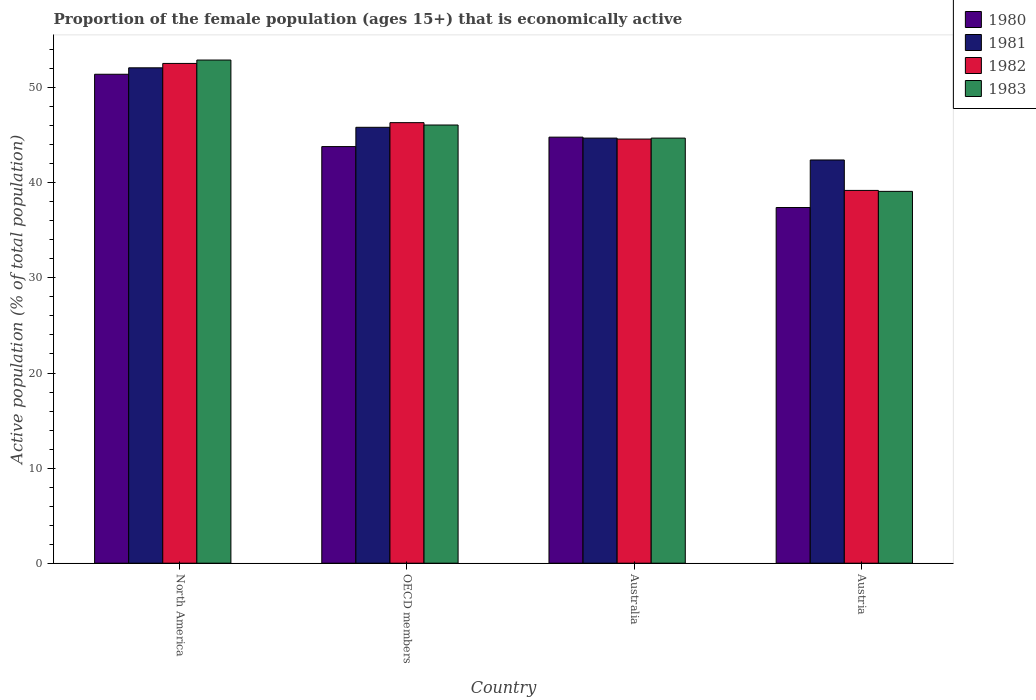How many different coloured bars are there?
Keep it short and to the point. 4. How many groups of bars are there?
Provide a succinct answer. 4. Are the number of bars per tick equal to the number of legend labels?
Give a very brief answer. Yes. Are the number of bars on each tick of the X-axis equal?
Provide a short and direct response. Yes. How many bars are there on the 4th tick from the left?
Your answer should be very brief. 4. What is the label of the 3rd group of bars from the left?
Provide a succinct answer. Australia. What is the proportion of the female population that is economically active in 1980 in OECD members?
Your response must be concise. 43.81. Across all countries, what is the maximum proportion of the female population that is economically active in 1982?
Offer a terse response. 52.55. Across all countries, what is the minimum proportion of the female population that is economically active in 1983?
Provide a succinct answer. 39.1. In which country was the proportion of the female population that is economically active in 1981 minimum?
Offer a very short reply. Austria. What is the total proportion of the female population that is economically active in 1980 in the graph?
Offer a very short reply. 177.42. What is the difference between the proportion of the female population that is economically active in 1981 in Australia and that in Austria?
Offer a terse response. 2.3. What is the difference between the proportion of the female population that is economically active in 1981 in Austria and the proportion of the female population that is economically active in 1980 in Australia?
Your answer should be compact. -2.4. What is the average proportion of the female population that is economically active in 1981 per country?
Keep it short and to the point. 46.26. What is the difference between the proportion of the female population that is economically active of/in 1981 and proportion of the female population that is economically active of/in 1980 in OECD members?
Your answer should be compact. 2.03. In how many countries, is the proportion of the female population that is economically active in 1983 greater than 52 %?
Offer a terse response. 1. What is the ratio of the proportion of the female population that is economically active in 1982 in Austria to that in North America?
Offer a very short reply. 0.75. Is the proportion of the female population that is economically active in 1980 in North America less than that in OECD members?
Offer a very short reply. No. What is the difference between the highest and the second highest proportion of the female population that is economically active in 1983?
Offer a very short reply. 6.83. What is the difference between the highest and the lowest proportion of the female population that is economically active in 1982?
Keep it short and to the point. 13.35. Is the sum of the proportion of the female population that is economically active in 1982 in Austria and North America greater than the maximum proportion of the female population that is economically active in 1983 across all countries?
Make the answer very short. Yes. What does the 2nd bar from the left in OECD members represents?
Make the answer very short. 1981. Is it the case that in every country, the sum of the proportion of the female population that is economically active in 1983 and proportion of the female population that is economically active in 1980 is greater than the proportion of the female population that is economically active in 1981?
Make the answer very short. Yes. Are all the bars in the graph horizontal?
Provide a short and direct response. No. Does the graph contain any zero values?
Provide a short and direct response. No. Where does the legend appear in the graph?
Make the answer very short. Top right. How many legend labels are there?
Give a very brief answer. 4. How are the legend labels stacked?
Your answer should be very brief. Vertical. What is the title of the graph?
Keep it short and to the point. Proportion of the female population (ages 15+) that is economically active. Does "1999" appear as one of the legend labels in the graph?
Your answer should be compact. No. What is the label or title of the Y-axis?
Ensure brevity in your answer.  Active population (% of total population). What is the Active population (% of total population) in 1980 in North America?
Provide a short and direct response. 51.41. What is the Active population (% of total population) in 1981 in North America?
Offer a very short reply. 52.09. What is the Active population (% of total population) of 1982 in North America?
Your response must be concise. 52.55. What is the Active population (% of total population) of 1983 in North America?
Provide a short and direct response. 52.91. What is the Active population (% of total population) in 1980 in OECD members?
Provide a short and direct response. 43.81. What is the Active population (% of total population) in 1981 in OECD members?
Offer a terse response. 45.84. What is the Active population (% of total population) of 1982 in OECD members?
Offer a very short reply. 46.32. What is the Active population (% of total population) of 1983 in OECD members?
Provide a succinct answer. 46.08. What is the Active population (% of total population) of 1980 in Australia?
Offer a terse response. 44.8. What is the Active population (% of total population) of 1981 in Australia?
Provide a short and direct response. 44.7. What is the Active population (% of total population) of 1982 in Australia?
Your response must be concise. 44.6. What is the Active population (% of total population) in 1983 in Australia?
Your answer should be very brief. 44.7. What is the Active population (% of total population) of 1980 in Austria?
Offer a very short reply. 37.4. What is the Active population (% of total population) of 1981 in Austria?
Offer a terse response. 42.4. What is the Active population (% of total population) in 1982 in Austria?
Provide a succinct answer. 39.2. What is the Active population (% of total population) in 1983 in Austria?
Your answer should be compact. 39.1. Across all countries, what is the maximum Active population (% of total population) of 1980?
Provide a succinct answer. 51.41. Across all countries, what is the maximum Active population (% of total population) of 1981?
Offer a very short reply. 52.09. Across all countries, what is the maximum Active population (% of total population) of 1982?
Your answer should be compact. 52.55. Across all countries, what is the maximum Active population (% of total population) of 1983?
Your response must be concise. 52.91. Across all countries, what is the minimum Active population (% of total population) in 1980?
Provide a succinct answer. 37.4. Across all countries, what is the minimum Active population (% of total population) of 1981?
Your answer should be very brief. 42.4. Across all countries, what is the minimum Active population (% of total population) of 1982?
Give a very brief answer. 39.2. Across all countries, what is the minimum Active population (% of total population) of 1983?
Provide a short and direct response. 39.1. What is the total Active population (% of total population) in 1980 in the graph?
Provide a short and direct response. 177.42. What is the total Active population (% of total population) in 1981 in the graph?
Make the answer very short. 185.03. What is the total Active population (% of total population) of 1982 in the graph?
Keep it short and to the point. 182.68. What is the total Active population (% of total population) in 1983 in the graph?
Make the answer very short. 182.79. What is the difference between the Active population (% of total population) in 1980 in North America and that in OECD members?
Your response must be concise. 7.61. What is the difference between the Active population (% of total population) of 1981 in North America and that in OECD members?
Ensure brevity in your answer.  6.25. What is the difference between the Active population (% of total population) of 1982 in North America and that in OECD members?
Your answer should be very brief. 6.23. What is the difference between the Active population (% of total population) in 1983 in North America and that in OECD members?
Keep it short and to the point. 6.83. What is the difference between the Active population (% of total population) in 1980 in North America and that in Australia?
Provide a succinct answer. 6.61. What is the difference between the Active population (% of total population) in 1981 in North America and that in Australia?
Provide a succinct answer. 7.39. What is the difference between the Active population (% of total population) in 1982 in North America and that in Australia?
Your answer should be compact. 7.95. What is the difference between the Active population (% of total population) in 1983 in North America and that in Australia?
Your answer should be very brief. 8.21. What is the difference between the Active population (% of total population) in 1980 in North America and that in Austria?
Keep it short and to the point. 14.01. What is the difference between the Active population (% of total population) of 1981 in North America and that in Austria?
Your response must be concise. 9.69. What is the difference between the Active population (% of total population) in 1982 in North America and that in Austria?
Your answer should be very brief. 13.35. What is the difference between the Active population (% of total population) of 1983 in North America and that in Austria?
Make the answer very short. 13.81. What is the difference between the Active population (% of total population) in 1980 in OECD members and that in Australia?
Your answer should be compact. -0.99. What is the difference between the Active population (% of total population) in 1981 in OECD members and that in Australia?
Provide a succinct answer. 1.14. What is the difference between the Active population (% of total population) of 1982 in OECD members and that in Australia?
Your response must be concise. 1.72. What is the difference between the Active population (% of total population) of 1983 in OECD members and that in Australia?
Your answer should be very brief. 1.38. What is the difference between the Active population (% of total population) in 1980 in OECD members and that in Austria?
Give a very brief answer. 6.41. What is the difference between the Active population (% of total population) in 1981 in OECD members and that in Austria?
Give a very brief answer. 3.44. What is the difference between the Active population (% of total population) of 1982 in OECD members and that in Austria?
Your answer should be compact. 7.12. What is the difference between the Active population (% of total population) in 1983 in OECD members and that in Austria?
Provide a short and direct response. 6.98. What is the difference between the Active population (% of total population) in 1981 in Australia and that in Austria?
Your answer should be compact. 2.3. What is the difference between the Active population (% of total population) of 1983 in Australia and that in Austria?
Give a very brief answer. 5.6. What is the difference between the Active population (% of total population) of 1980 in North America and the Active population (% of total population) of 1981 in OECD members?
Provide a short and direct response. 5.58. What is the difference between the Active population (% of total population) in 1980 in North America and the Active population (% of total population) in 1982 in OECD members?
Provide a succinct answer. 5.09. What is the difference between the Active population (% of total population) of 1980 in North America and the Active population (% of total population) of 1983 in OECD members?
Your answer should be compact. 5.34. What is the difference between the Active population (% of total population) in 1981 in North America and the Active population (% of total population) in 1982 in OECD members?
Offer a very short reply. 5.77. What is the difference between the Active population (% of total population) in 1981 in North America and the Active population (% of total population) in 1983 in OECD members?
Ensure brevity in your answer.  6.01. What is the difference between the Active population (% of total population) in 1982 in North America and the Active population (% of total population) in 1983 in OECD members?
Ensure brevity in your answer.  6.47. What is the difference between the Active population (% of total population) in 1980 in North America and the Active population (% of total population) in 1981 in Australia?
Give a very brief answer. 6.71. What is the difference between the Active population (% of total population) in 1980 in North America and the Active population (% of total population) in 1982 in Australia?
Offer a terse response. 6.81. What is the difference between the Active population (% of total population) of 1980 in North America and the Active population (% of total population) of 1983 in Australia?
Keep it short and to the point. 6.71. What is the difference between the Active population (% of total population) of 1981 in North America and the Active population (% of total population) of 1982 in Australia?
Give a very brief answer. 7.49. What is the difference between the Active population (% of total population) in 1981 in North America and the Active population (% of total population) in 1983 in Australia?
Offer a terse response. 7.39. What is the difference between the Active population (% of total population) in 1982 in North America and the Active population (% of total population) in 1983 in Australia?
Your response must be concise. 7.85. What is the difference between the Active population (% of total population) in 1980 in North America and the Active population (% of total population) in 1981 in Austria?
Give a very brief answer. 9.01. What is the difference between the Active population (% of total population) of 1980 in North America and the Active population (% of total population) of 1982 in Austria?
Make the answer very short. 12.21. What is the difference between the Active population (% of total population) of 1980 in North America and the Active population (% of total population) of 1983 in Austria?
Offer a very short reply. 12.31. What is the difference between the Active population (% of total population) in 1981 in North America and the Active population (% of total population) in 1982 in Austria?
Offer a very short reply. 12.89. What is the difference between the Active population (% of total population) in 1981 in North America and the Active population (% of total population) in 1983 in Austria?
Ensure brevity in your answer.  12.99. What is the difference between the Active population (% of total population) in 1982 in North America and the Active population (% of total population) in 1983 in Austria?
Your answer should be compact. 13.45. What is the difference between the Active population (% of total population) in 1980 in OECD members and the Active population (% of total population) in 1981 in Australia?
Offer a very short reply. -0.89. What is the difference between the Active population (% of total population) of 1980 in OECD members and the Active population (% of total population) of 1982 in Australia?
Offer a very short reply. -0.79. What is the difference between the Active population (% of total population) of 1980 in OECD members and the Active population (% of total population) of 1983 in Australia?
Your answer should be very brief. -0.89. What is the difference between the Active population (% of total population) in 1981 in OECD members and the Active population (% of total population) in 1982 in Australia?
Offer a very short reply. 1.24. What is the difference between the Active population (% of total population) in 1981 in OECD members and the Active population (% of total population) in 1983 in Australia?
Provide a succinct answer. 1.14. What is the difference between the Active population (% of total population) in 1982 in OECD members and the Active population (% of total population) in 1983 in Australia?
Your answer should be very brief. 1.62. What is the difference between the Active population (% of total population) in 1980 in OECD members and the Active population (% of total population) in 1981 in Austria?
Give a very brief answer. 1.41. What is the difference between the Active population (% of total population) in 1980 in OECD members and the Active population (% of total population) in 1982 in Austria?
Ensure brevity in your answer.  4.61. What is the difference between the Active population (% of total population) of 1980 in OECD members and the Active population (% of total population) of 1983 in Austria?
Ensure brevity in your answer.  4.71. What is the difference between the Active population (% of total population) of 1981 in OECD members and the Active population (% of total population) of 1982 in Austria?
Your answer should be very brief. 6.64. What is the difference between the Active population (% of total population) of 1981 in OECD members and the Active population (% of total population) of 1983 in Austria?
Provide a succinct answer. 6.74. What is the difference between the Active population (% of total population) of 1982 in OECD members and the Active population (% of total population) of 1983 in Austria?
Provide a succinct answer. 7.22. What is the difference between the Active population (% of total population) of 1980 in Australia and the Active population (% of total population) of 1981 in Austria?
Keep it short and to the point. 2.4. What is the difference between the Active population (% of total population) in 1980 in Australia and the Active population (% of total population) in 1982 in Austria?
Your response must be concise. 5.6. What is the difference between the Active population (% of total population) in 1980 in Australia and the Active population (% of total population) in 1983 in Austria?
Your response must be concise. 5.7. What is the difference between the Active population (% of total population) of 1981 in Australia and the Active population (% of total population) of 1983 in Austria?
Offer a terse response. 5.6. What is the average Active population (% of total population) of 1980 per country?
Give a very brief answer. 44.36. What is the average Active population (% of total population) of 1981 per country?
Make the answer very short. 46.26. What is the average Active population (% of total population) in 1982 per country?
Provide a short and direct response. 45.67. What is the average Active population (% of total population) of 1983 per country?
Your answer should be compact. 45.7. What is the difference between the Active population (% of total population) of 1980 and Active population (% of total population) of 1981 in North America?
Your response must be concise. -0.68. What is the difference between the Active population (% of total population) in 1980 and Active population (% of total population) in 1982 in North America?
Your answer should be very brief. -1.14. What is the difference between the Active population (% of total population) in 1980 and Active population (% of total population) in 1983 in North America?
Your response must be concise. -1.5. What is the difference between the Active population (% of total population) in 1981 and Active population (% of total population) in 1982 in North America?
Your answer should be very brief. -0.46. What is the difference between the Active population (% of total population) in 1981 and Active population (% of total population) in 1983 in North America?
Give a very brief answer. -0.82. What is the difference between the Active population (% of total population) of 1982 and Active population (% of total population) of 1983 in North America?
Provide a succinct answer. -0.36. What is the difference between the Active population (% of total population) of 1980 and Active population (% of total population) of 1981 in OECD members?
Your answer should be compact. -2.03. What is the difference between the Active population (% of total population) in 1980 and Active population (% of total population) in 1982 in OECD members?
Ensure brevity in your answer.  -2.52. What is the difference between the Active population (% of total population) of 1980 and Active population (% of total population) of 1983 in OECD members?
Your answer should be very brief. -2.27. What is the difference between the Active population (% of total population) of 1981 and Active population (% of total population) of 1982 in OECD members?
Make the answer very short. -0.49. What is the difference between the Active population (% of total population) of 1981 and Active population (% of total population) of 1983 in OECD members?
Keep it short and to the point. -0.24. What is the difference between the Active population (% of total population) in 1982 and Active population (% of total population) in 1983 in OECD members?
Your answer should be compact. 0.25. What is the difference between the Active population (% of total population) in 1980 and Active population (% of total population) in 1982 in Australia?
Ensure brevity in your answer.  0.2. What is the difference between the Active population (% of total population) of 1980 and Active population (% of total population) of 1983 in Australia?
Your response must be concise. 0.1. What is the difference between the Active population (% of total population) in 1981 and Active population (% of total population) in 1982 in Australia?
Your answer should be compact. 0.1. What is the difference between the Active population (% of total population) of 1981 and Active population (% of total population) of 1983 in Australia?
Provide a succinct answer. 0. What is the difference between the Active population (% of total population) in 1980 and Active population (% of total population) in 1982 in Austria?
Keep it short and to the point. -1.8. What is the difference between the Active population (% of total population) of 1980 and Active population (% of total population) of 1983 in Austria?
Your answer should be compact. -1.7. What is the difference between the Active population (% of total population) of 1982 and Active population (% of total population) of 1983 in Austria?
Your answer should be compact. 0.1. What is the ratio of the Active population (% of total population) in 1980 in North America to that in OECD members?
Make the answer very short. 1.17. What is the ratio of the Active population (% of total population) of 1981 in North America to that in OECD members?
Offer a very short reply. 1.14. What is the ratio of the Active population (% of total population) of 1982 in North America to that in OECD members?
Your answer should be very brief. 1.13. What is the ratio of the Active population (% of total population) in 1983 in North America to that in OECD members?
Offer a terse response. 1.15. What is the ratio of the Active population (% of total population) of 1980 in North America to that in Australia?
Your answer should be compact. 1.15. What is the ratio of the Active population (% of total population) of 1981 in North America to that in Australia?
Offer a terse response. 1.17. What is the ratio of the Active population (% of total population) in 1982 in North America to that in Australia?
Your answer should be very brief. 1.18. What is the ratio of the Active population (% of total population) in 1983 in North America to that in Australia?
Provide a short and direct response. 1.18. What is the ratio of the Active population (% of total population) of 1980 in North America to that in Austria?
Provide a short and direct response. 1.37. What is the ratio of the Active population (% of total population) in 1981 in North America to that in Austria?
Your answer should be compact. 1.23. What is the ratio of the Active population (% of total population) of 1982 in North America to that in Austria?
Keep it short and to the point. 1.34. What is the ratio of the Active population (% of total population) in 1983 in North America to that in Austria?
Provide a short and direct response. 1.35. What is the ratio of the Active population (% of total population) in 1980 in OECD members to that in Australia?
Keep it short and to the point. 0.98. What is the ratio of the Active population (% of total population) in 1981 in OECD members to that in Australia?
Offer a terse response. 1.03. What is the ratio of the Active population (% of total population) in 1982 in OECD members to that in Australia?
Keep it short and to the point. 1.04. What is the ratio of the Active population (% of total population) in 1983 in OECD members to that in Australia?
Your answer should be compact. 1.03. What is the ratio of the Active population (% of total population) in 1980 in OECD members to that in Austria?
Provide a short and direct response. 1.17. What is the ratio of the Active population (% of total population) in 1981 in OECD members to that in Austria?
Keep it short and to the point. 1.08. What is the ratio of the Active population (% of total population) in 1982 in OECD members to that in Austria?
Provide a short and direct response. 1.18. What is the ratio of the Active population (% of total population) of 1983 in OECD members to that in Austria?
Offer a terse response. 1.18. What is the ratio of the Active population (% of total population) in 1980 in Australia to that in Austria?
Ensure brevity in your answer.  1.2. What is the ratio of the Active population (% of total population) of 1981 in Australia to that in Austria?
Give a very brief answer. 1.05. What is the ratio of the Active population (% of total population) in 1982 in Australia to that in Austria?
Offer a terse response. 1.14. What is the ratio of the Active population (% of total population) of 1983 in Australia to that in Austria?
Your response must be concise. 1.14. What is the difference between the highest and the second highest Active population (% of total population) in 1980?
Make the answer very short. 6.61. What is the difference between the highest and the second highest Active population (% of total population) in 1981?
Your answer should be compact. 6.25. What is the difference between the highest and the second highest Active population (% of total population) of 1982?
Offer a very short reply. 6.23. What is the difference between the highest and the second highest Active population (% of total population) in 1983?
Ensure brevity in your answer.  6.83. What is the difference between the highest and the lowest Active population (% of total population) of 1980?
Keep it short and to the point. 14.01. What is the difference between the highest and the lowest Active population (% of total population) in 1981?
Provide a short and direct response. 9.69. What is the difference between the highest and the lowest Active population (% of total population) of 1982?
Ensure brevity in your answer.  13.35. What is the difference between the highest and the lowest Active population (% of total population) of 1983?
Give a very brief answer. 13.81. 